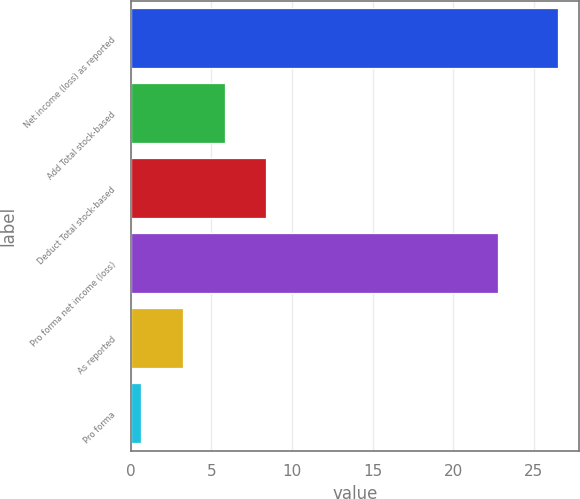<chart> <loc_0><loc_0><loc_500><loc_500><bar_chart><fcel>Net income (loss) as reported<fcel>Add Total stock-based<fcel>Deduct Total stock-based<fcel>Pro forma net income (loss)<fcel>As reported<fcel>Pro forma<nl><fcel>26.5<fcel>5.83<fcel>8.42<fcel>22.8<fcel>3.24<fcel>0.65<nl></chart> 